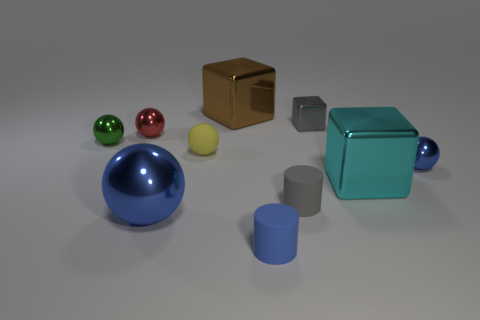How many blue metallic balls have the same size as the blue matte cylinder?
Provide a short and direct response. 1. The metallic thing that is the same color as the big metallic sphere is what shape?
Keep it short and to the point. Sphere. What is the shape of the blue metallic thing that is to the left of the small ball to the right of the cyan shiny block in front of the small gray metal cube?
Offer a very short reply. Sphere. What is the color of the ball to the right of the small gray shiny object?
Keep it short and to the point. Blue. What number of things are either small shiny objects in front of the small red sphere or small things that are to the right of the red metallic ball?
Your response must be concise. 6. What number of tiny red objects are the same shape as the small gray rubber thing?
Keep it short and to the point. 0. There is a block that is the same size as the red sphere; what is its color?
Offer a very short reply. Gray. There is a big block on the left side of the matte cylinder that is in front of the blue metallic thing that is on the left side of the brown shiny object; what color is it?
Your response must be concise. Brown. Do the red metallic ball and the metal ball in front of the small blue metallic ball have the same size?
Provide a short and direct response. No. What number of objects are green rubber balls or rubber cylinders?
Provide a short and direct response. 2. 